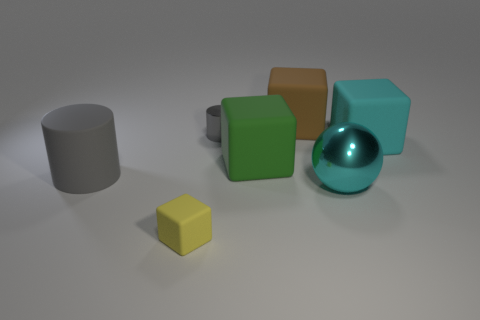What number of other objects are there of the same color as the sphere?
Give a very brief answer. 1. Is the number of large gray cylinders less than the number of green rubber balls?
Keep it short and to the point. No. How many small yellow rubber blocks are to the right of the large matte cube behind the cylinder that is behind the large green matte object?
Your response must be concise. 0. There is a cylinder in front of the big cyan cube; what is its size?
Provide a succinct answer. Large. Is the shape of the rubber object behind the large cyan cube the same as  the green thing?
Make the answer very short. Yes. What is the material of the other tiny object that is the same shape as the gray rubber thing?
Provide a short and direct response. Metal. Is there a tiny block?
Your answer should be compact. Yes. The cyan sphere that is right of the gray cylinder that is on the right side of the gray object in front of the small cylinder is made of what material?
Your answer should be very brief. Metal. Do the tiny yellow matte object and the big cyan thing that is behind the large gray object have the same shape?
Make the answer very short. Yes. What number of big green objects have the same shape as the small gray object?
Make the answer very short. 0. 